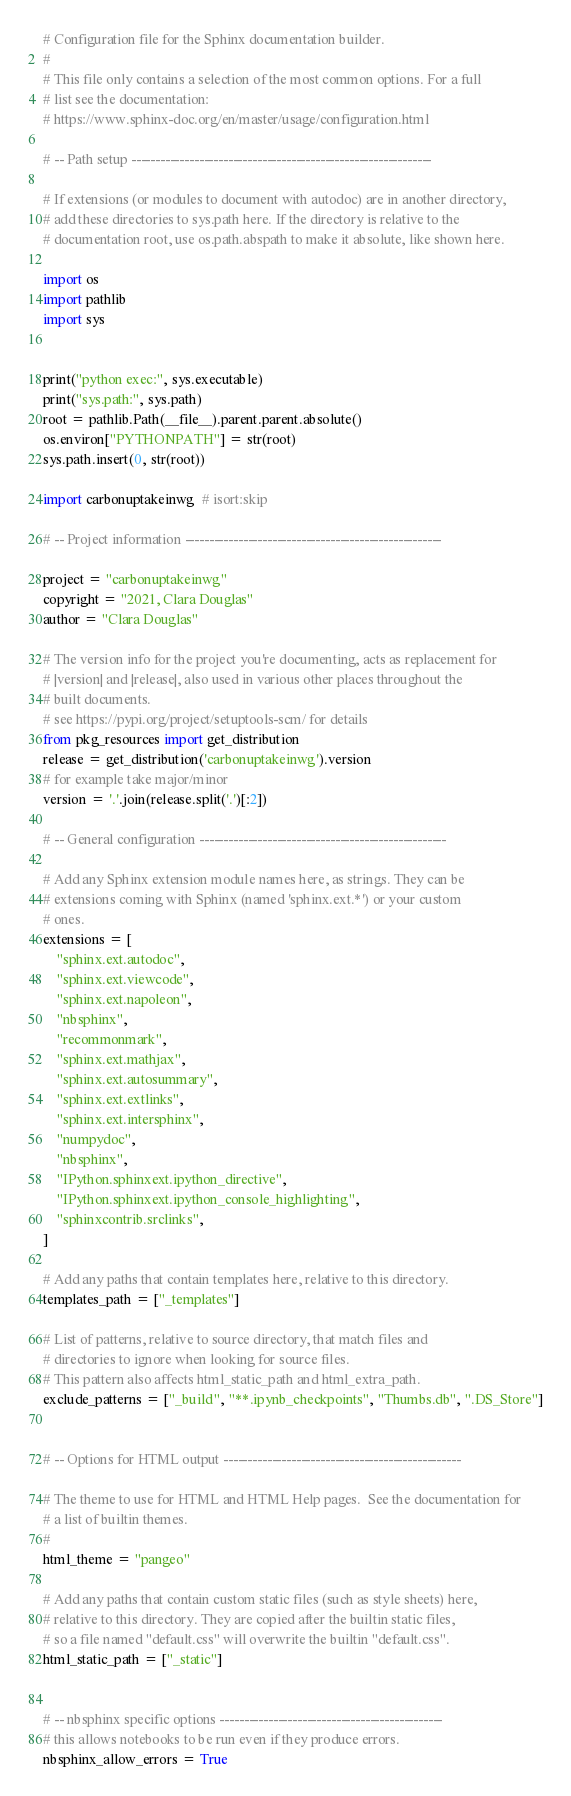<code> <loc_0><loc_0><loc_500><loc_500><_Python_># Configuration file for the Sphinx documentation builder.
#
# This file only contains a selection of the most common options. For a full
# list see the documentation:
# https://www.sphinx-doc.org/en/master/usage/configuration.html

# -- Path setup --------------------------------------------------------------

# If extensions (or modules to document with autodoc) are in another directory,
# add these directories to sys.path here. If the directory is relative to the
# documentation root, use os.path.abspath to make it absolute, like shown here.

import os
import pathlib
import sys


print("python exec:", sys.executable)
print("sys.path:", sys.path)
root = pathlib.Path(__file__).parent.parent.absolute()
os.environ["PYTHONPATH"] = str(root)
sys.path.insert(0, str(root))

import carbonuptakeinwg  # isort:skip

# -- Project information -----------------------------------------------------

project = "carbonuptakeinwg"
copyright = "2021, Clara Douglas"
author = "Clara Douglas"

# The version info for the project you're documenting, acts as replacement for
# |version| and |release|, also used in various other places throughout the
# built documents.
# see https://pypi.org/project/setuptools-scm/ for details
from pkg_resources import get_distribution
release = get_distribution('carbonuptakeinwg').version
# for example take major/minor
version = '.'.join(release.split('.')[:2])

# -- General configuration ---------------------------------------------------

# Add any Sphinx extension module names here, as strings. They can be
# extensions coming with Sphinx (named 'sphinx.ext.*') or your custom
# ones.
extensions = [
    "sphinx.ext.autodoc",
    "sphinx.ext.viewcode",
    "sphinx.ext.napoleon",
    "nbsphinx",
    "recommonmark",
    "sphinx.ext.mathjax",
    "sphinx.ext.autosummary",
    "sphinx.ext.extlinks",
    "sphinx.ext.intersphinx",
    "numpydoc",
    "nbsphinx",
    "IPython.sphinxext.ipython_directive",
    "IPython.sphinxext.ipython_console_highlighting",
    "sphinxcontrib.srclinks",
]

# Add any paths that contain templates here, relative to this directory.
templates_path = ["_templates"]

# List of patterns, relative to source directory, that match files and
# directories to ignore when looking for source files.
# This pattern also affects html_static_path and html_extra_path.
exclude_patterns = ["_build", "**.ipynb_checkpoints", "Thumbs.db", ".DS_Store"]


# -- Options for HTML output -------------------------------------------------

# The theme to use for HTML and HTML Help pages.  See the documentation for
# a list of builtin themes.
#
html_theme = "pangeo"

# Add any paths that contain custom static files (such as style sheets) here,
# relative to this directory. They are copied after the builtin static files,
# so a file named "default.css" will overwrite the builtin "default.css".
html_static_path = ["_static"]


# -- nbsphinx specific options ----------------------------------------------
# this allows notebooks to be run even if they produce errors.
nbsphinx_allow_errors = True</code> 